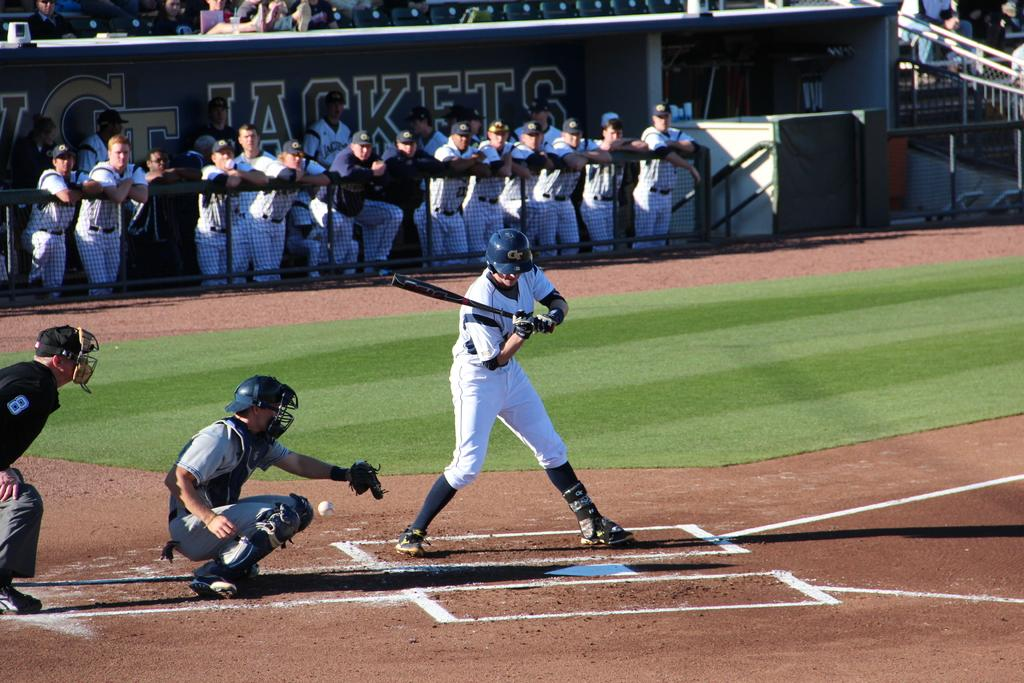<image>
Create a compact narrative representing the image presented. Ball player dugout that reads Jackets in dark lettering. 